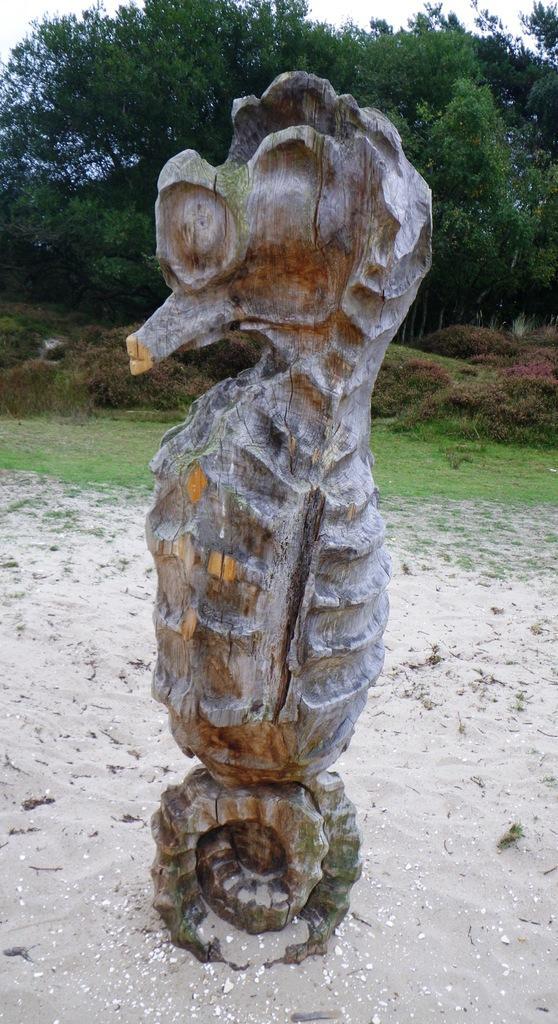Could you give a brief overview of what you see in this image? In the picture I can see a sculpture. In the background I can see trees, the sky and the grass. 